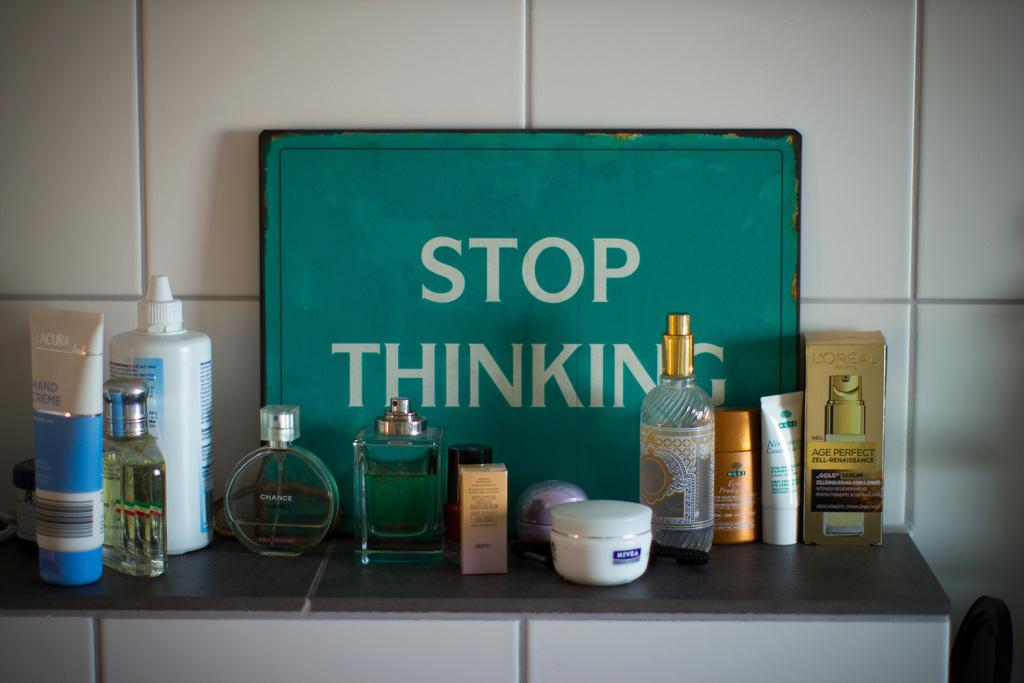<image>
Offer a succinct explanation of the picture presented. Sign that says Stop Thinking along with perfume bottles on a shelf. 